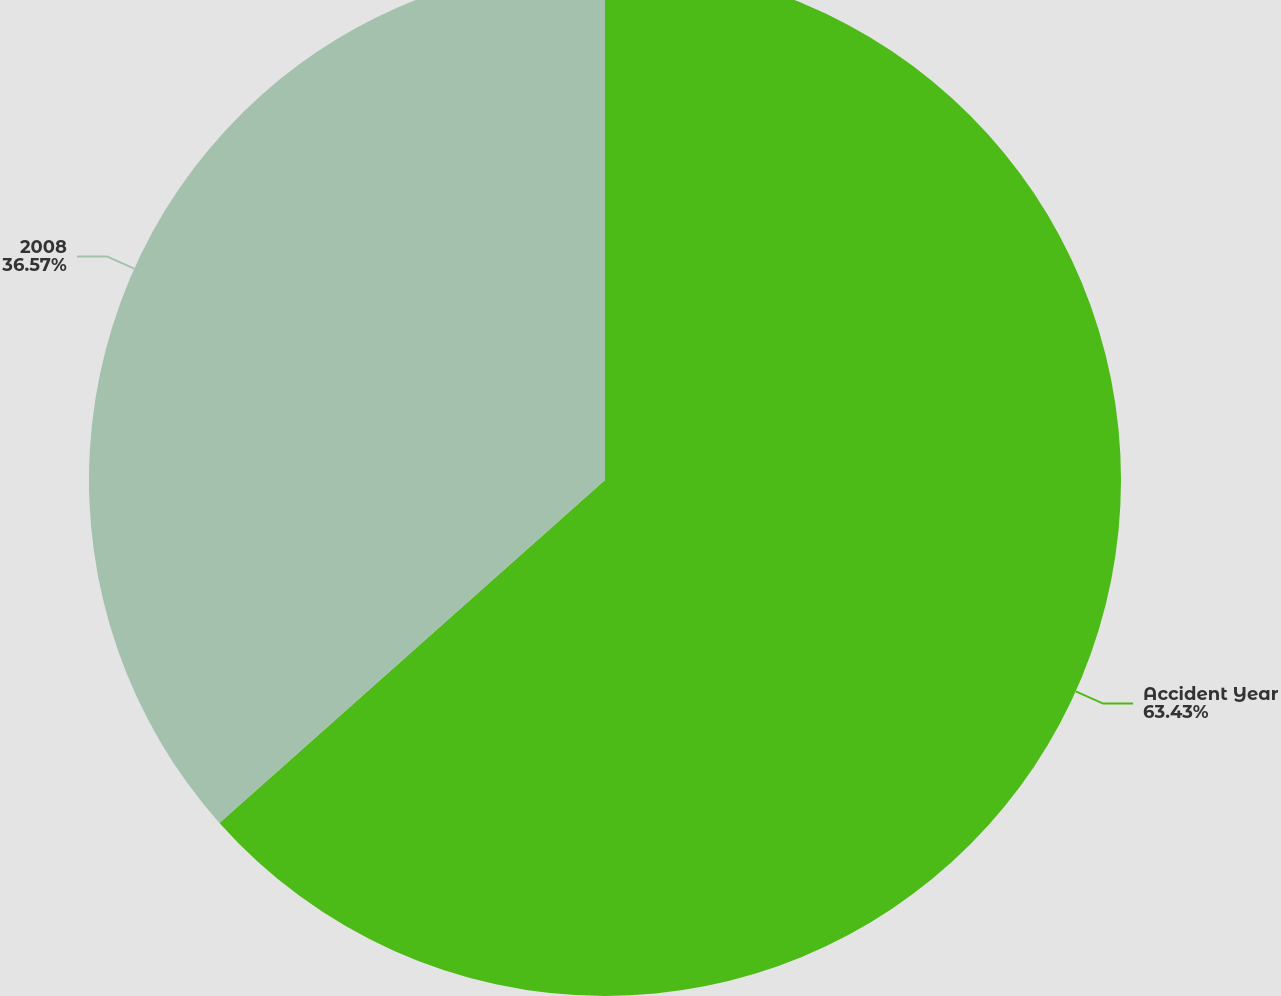Convert chart. <chart><loc_0><loc_0><loc_500><loc_500><pie_chart><fcel>Accident Year<fcel>2008<nl><fcel>63.43%<fcel>36.57%<nl></chart> 